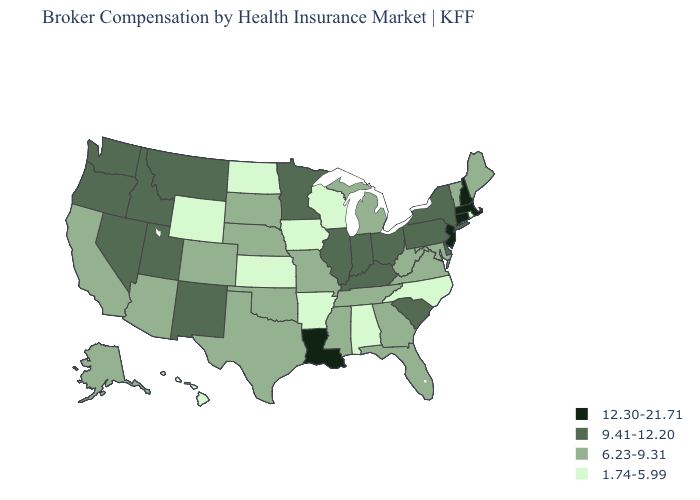Name the states that have a value in the range 9.41-12.20?
Write a very short answer. Delaware, Idaho, Illinois, Indiana, Kentucky, Minnesota, Montana, Nevada, New Mexico, New York, Ohio, Oregon, Pennsylvania, South Carolina, Utah, Washington. What is the value of Arkansas?
Keep it brief. 1.74-5.99. What is the value of Florida?
Keep it brief. 6.23-9.31. What is the lowest value in the USA?
Keep it brief. 1.74-5.99. Among the states that border Kentucky , does Ohio have the lowest value?
Give a very brief answer. No. Which states have the lowest value in the Northeast?
Keep it brief. Rhode Island. Which states have the lowest value in the USA?
Concise answer only. Alabama, Arkansas, Hawaii, Iowa, Kansas, North Carolina, North Dakota, Rhode Island, Wisconsin, Wyoming. Name the states that have a value in the range 12.30-21.71?
Answer briefly. Connecticut, Louisiana, Massachusetts, New Hampshire, New Jersey. Does the map have missing data?
Write a very short answer. No. Does Tennessee have a higher value than Rhode Island?
Keep it brief. Yes. What is the value of North Carolina?
Be succinct. 1.74-5.99. Name the states that have a value in the range 1.74-5.99?
Answer briefly. Alabama, Arkansas, Hawaii, Iowa, Kansas, North Carolina, North Dakota, Rhode Island, Wisconsin, Wyoming. What is the value of New Mexico?
Quick response, please. 9.41-12.20. What is the value of Florida?
Be succinct. 6.23-9.31. What is the lowest value in the MidWest?
Answer briefly. 1.74-5.99. 